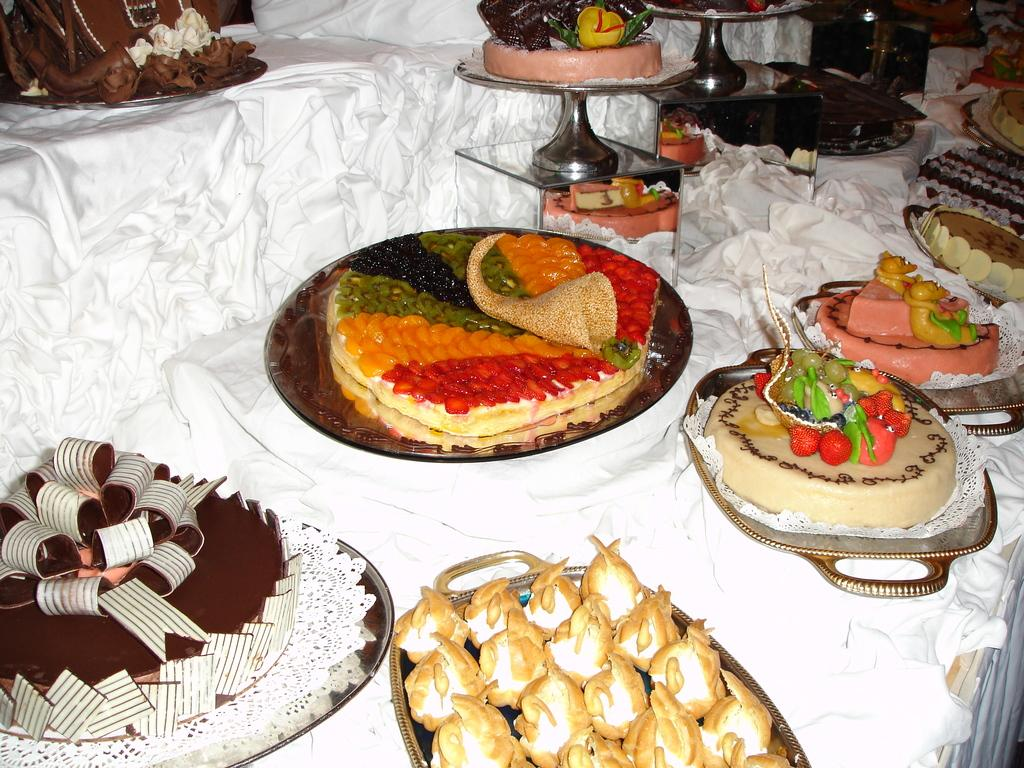What objects are present in the image that are used for serving food? There are plates in the image. What can be found on the plates in the image? The plates contain different food items. What type of bead is used as a decoration on the plates in the image? There are no beads present on the plates in the image; they contain different food items. 